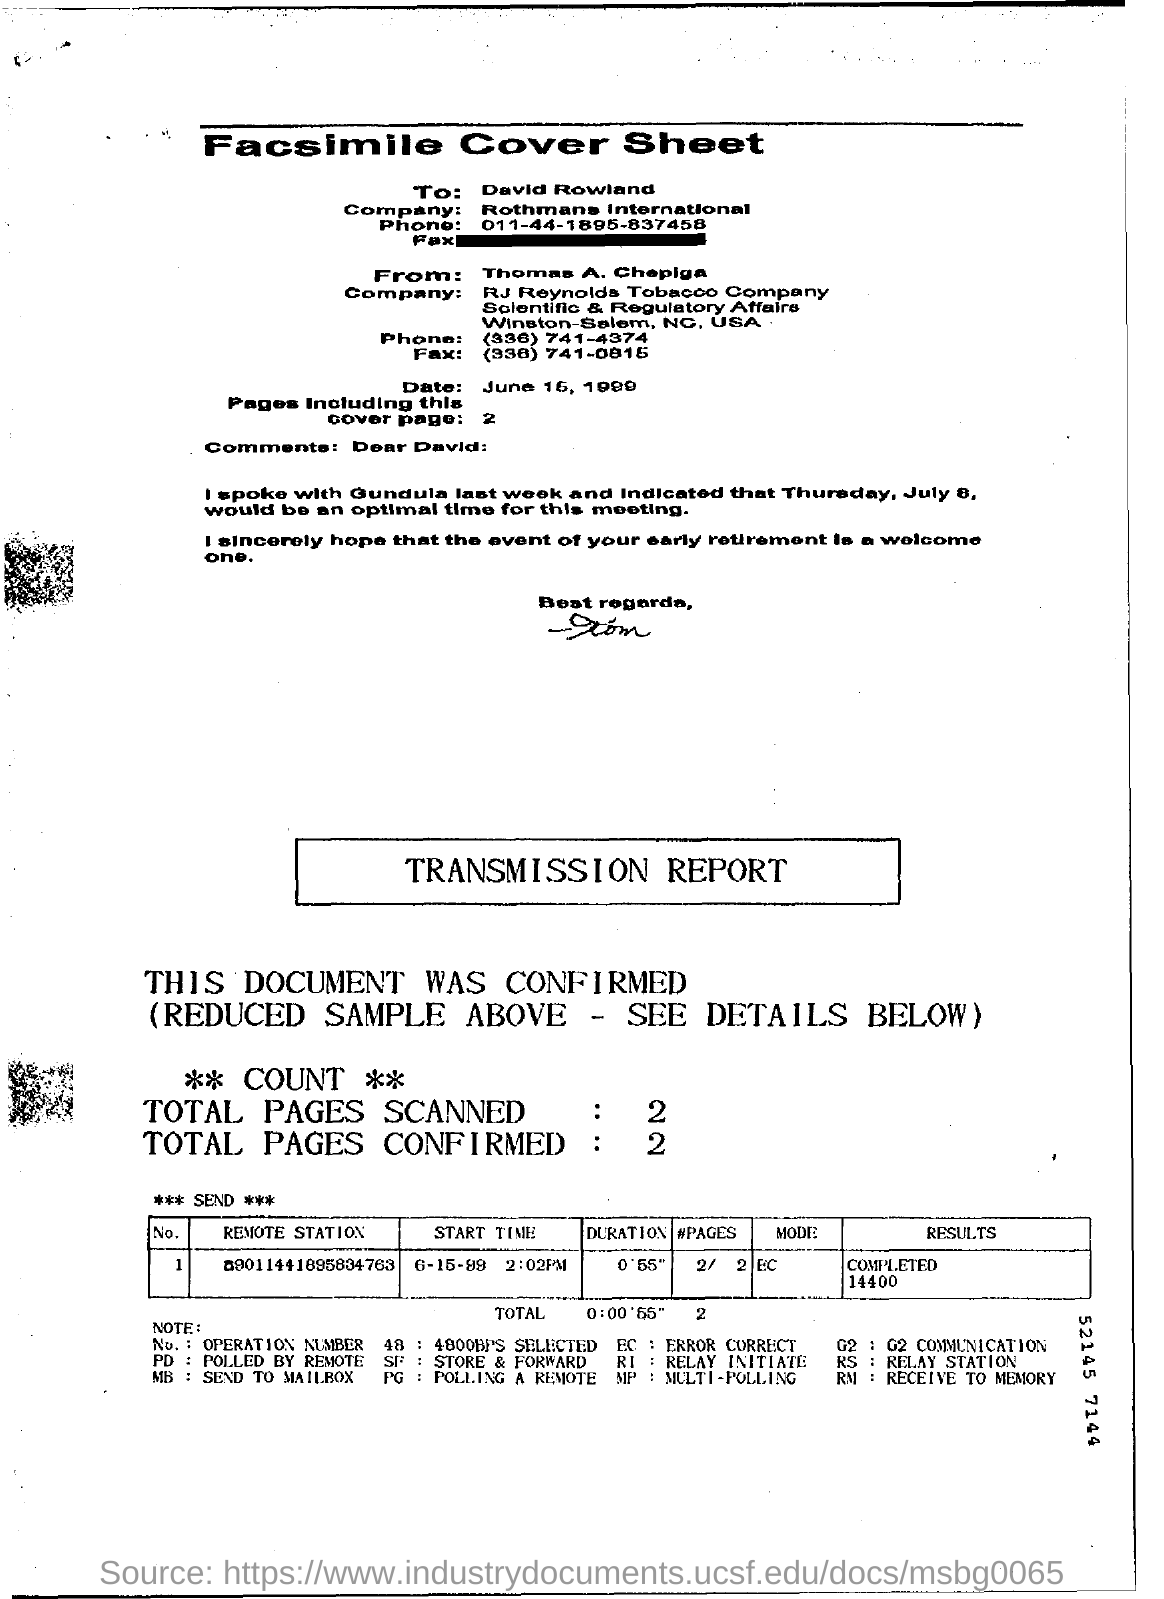Mention a couple of crucial points in this snapshot. The cover sheet is addressed to David Rowland. The duration mentioned in the report is 55 seconds. The report indicates that a total of two pages were scanned. The report includes 2 total pages. There are 2 pages, including this cover page, in total. 